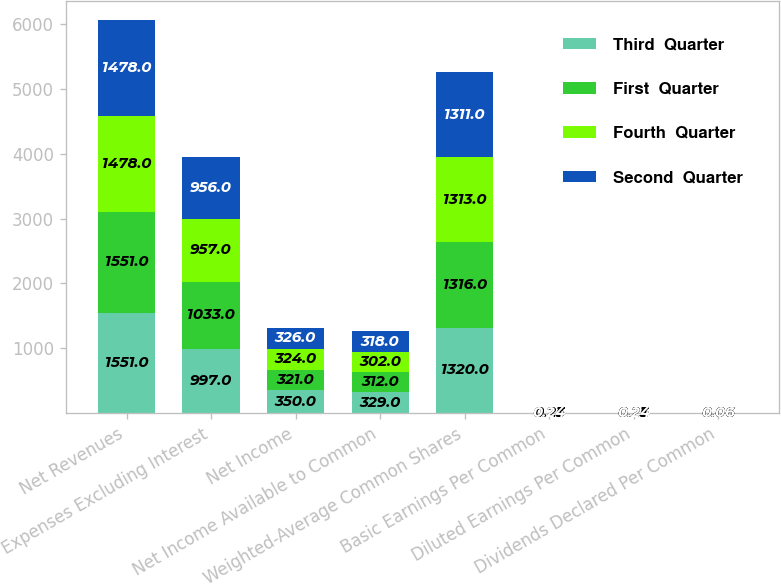<chart> <loc_0><loc_0><loc_500><loc_500><stacked_bar_chart><ecel><fcel>Net Revenues<fcel>Expenses Excluding Interest<fcel>Net Income<fcel>Net Income Available to Common<fcel>Weighted-Average Common Shares<fcel>Basic Earnings Per Common<fcel>Diluted Earnings Per Common<fcel>Dividends Declared Per Common<nl><fcel>Third  Quarter<fcel>1551<fcel>997<fcel>350<fcel>329<fcel>1320<fcel>0.25<fcel>0.25<fcel>0.06<nl><fcel>First  Quarter<fcel>1551<fcel>1033<fcel>321<fcel>312<fcel>1316<fcel>0.24<fcel>0.24<fcel>0.06<nl><fcel>Fourth  Quarter<fcel>1478<fcel>957<fcel>324<fcel>302<fcel>1313<fcel>0.23<fcel>0.23<fcel>0.06<nl><fcel>Second  Quarter<fcel>1478<fcel>956<fcel>326<fcel>318<fcel>1311<fcel>0.24<fcel>0.24<fcel>0.06<nl></chart> 